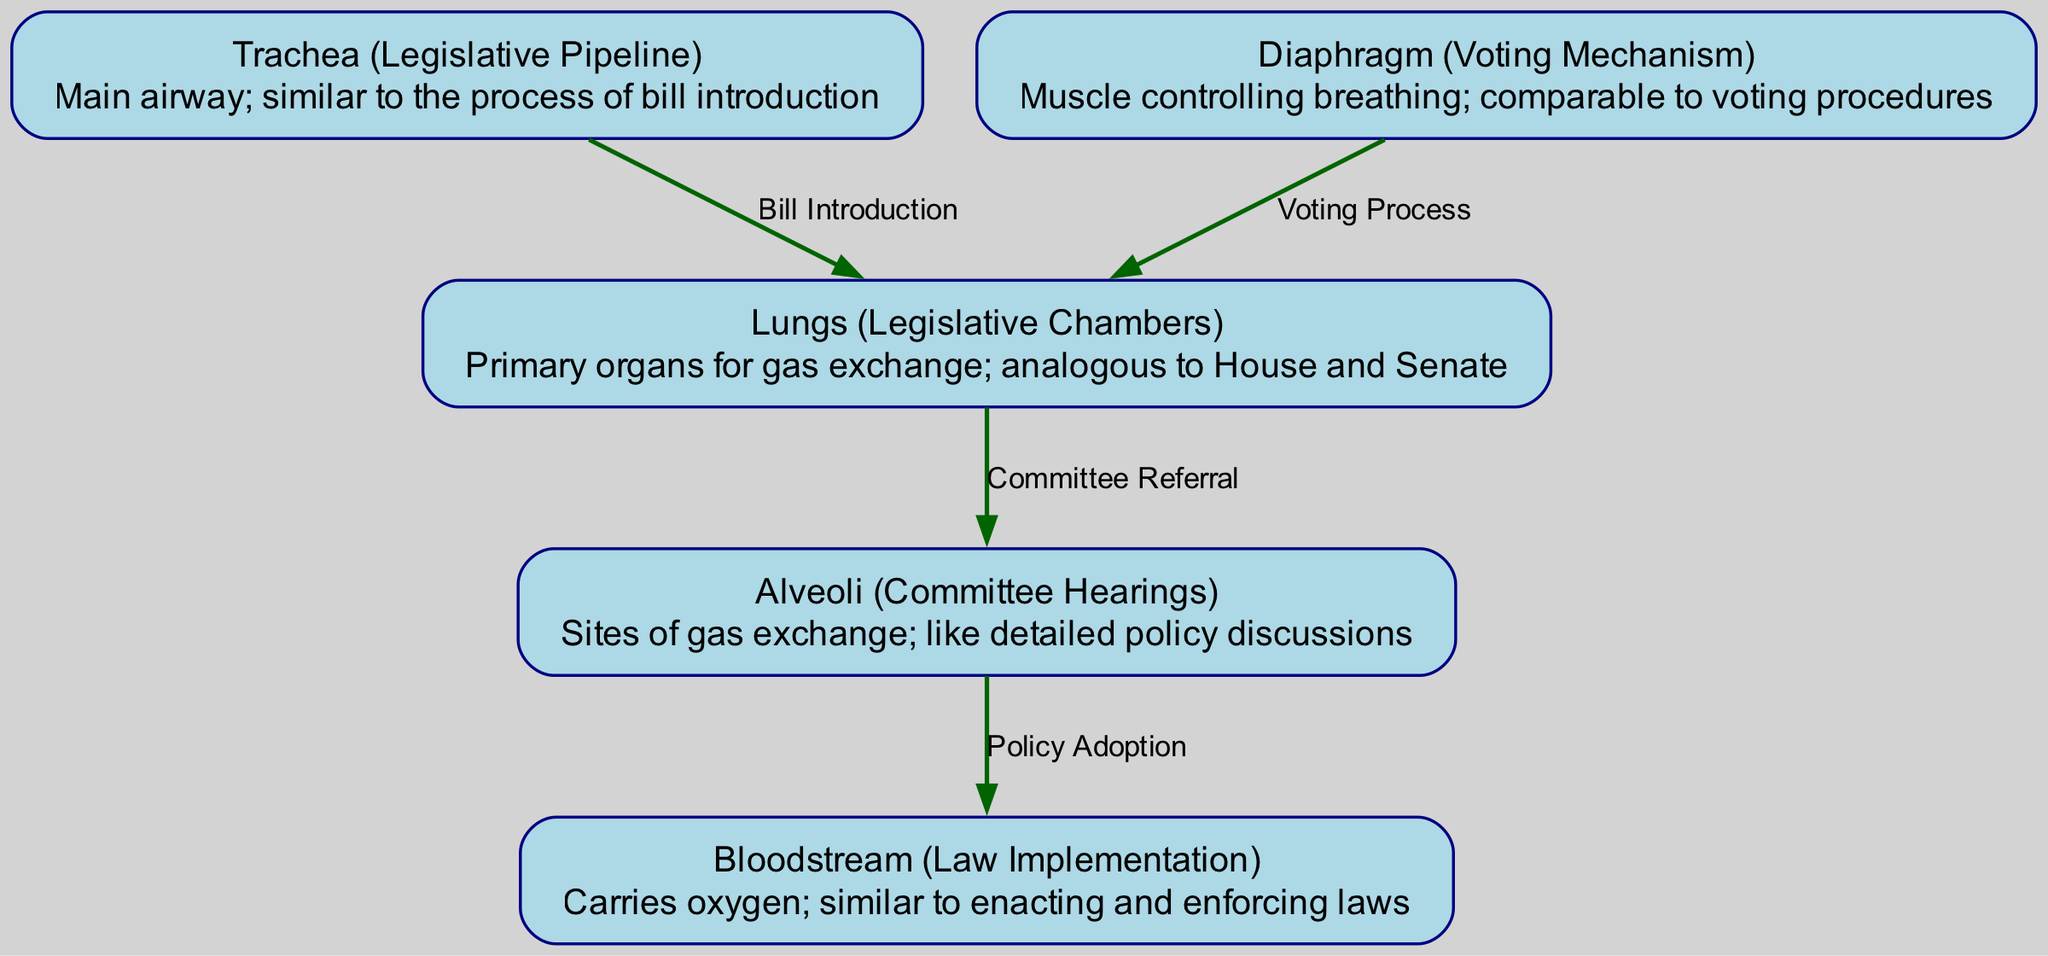What are the primary organs for gas exchange in this diagram? The diagram indicates that the 'Lungs' serve as the primary organs for gas exchange, which are comparable to legislative chambers such as the House and Senate.
Answer: Lungs How many nodes are present in the diagram? By counting the nodes listed, there are a total of five nodes: Lungs, Trachea, Diaphragm, Alveoli, and Bloodstream.
Answer: Five What is the role of the diaphragm in this analogy? The 'Diaphragm', in this context, is represented as the 'Voting Mechanism', which indicates its function in controlling the breathing process, analogous to voting procedures in legislative bodies.
Answer: Voting Mechanism Which node is connected to the lungs and what is that connection labeled? The node 'Trachea' is connected to the 'Lungs', and the connection is labeled 'Bill Introduction', highlighting the initial stage in the legislative process.
Answer: Trachea, Bill Introduction What does the alveoli represent in this diagram? In the diagram, the 'Alveoli' represent 'Committee Hearings', which are sites for detailed discussions, analogous to where the crucial gas exchange occurs in the respiratory system.
Answer: Committee Hearings What process does the diaphragm relate to when connected to the lungs? The connection between the 'Diaphragm' and 'Lungs' is labeled as the 'Voting Process', indicating the role of voting in facilitating action within legislative chambers, akin to breathing.
Answer: Voting Process From which node does the flow of oxygen begin, and what is its analogy? The flow of oxygen begins at the 'Lungs', which are analogous to the 'Legislative Chambers', as they initiate the gas exchange process much like chambers review introduced legislation.
Answer: Lungs What do the edges from alveoli to the bloodstream indicate? The edge from 'Alveoli' to 'Bloodstream' is labeled 'Policy Adoption', which signifies the transfer of adopted policies post discussions in committees, precisely like oxygen entering the bloodstream.
Answer: Policy Adoption 